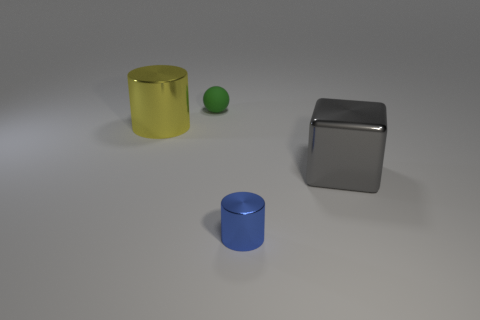Are there more objects behind the big yellow metallic cylinder than big yellow metallic things right of the large metallic cube?
Provide a succinct answer. Yes. What number of spheres are small shiny objects or tiny things?
Your answer should be very brief. 1. How many things are cylinders behind the big gray metal thing or big cylinders?
Give a very brief answer. 1. The thing left of the tiny thing that is behind the metallic object that is to the left of the small green matte thing is what shape?
Keep it short and to the point. Cylinder. How many gray shiny objects have the same shape as the small green object?
Offer a very short reply. 0. Is the material of the large cube the same as the tiny cylinder?
Keep it short and to the point. Yes. There is a metallic cylinder in front of the big metallic thing on the right side of the large yellow metal object; what number of large metallic cubes are behind it?
Provide a succinct answer. 1. Is there a cube that has the same material as the large yellow cylinder?
Offer a very short reply. Yes. Are there fewer blue metallic things than brown shiny cylinders?
Keep it short and to the point. No. There is a metallic cylinder that is in front of the large gray cube; does it have the same color as the small matte object?
Keep it short and to the point. No. 